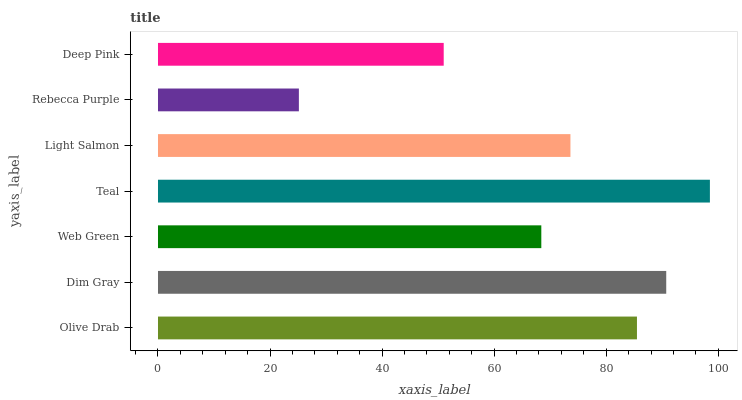Is Rebecca Purple the minimum?
Answer yes or no. Yes. Is Teal the maximum?
Answer yes or no. Yes. Is Dim Gray the minimum?
Answer yes or no. No. Is Dim Gray the maximum?
Answer yes or no. No. Is Dim Gray greater than Olive Drab?
Answer yes or no. Yes. Is Olive Drab less than Dim Gray?
Answer yes or no. Yes. Is Olive Drab greater than Dim Gray?
Answer yes or no. No. Is Dim Gray less than Olive Drab?
Answer yes or no. No. Is Light Salmon the high median?
Answer yes or no. Yes. Is Light Salmon the low median?
Answer yes or no. Yes. Is Web Green the high median?
Answer yes or no. No. Is Olive Drab the low median?
Answer yes or no. No. 